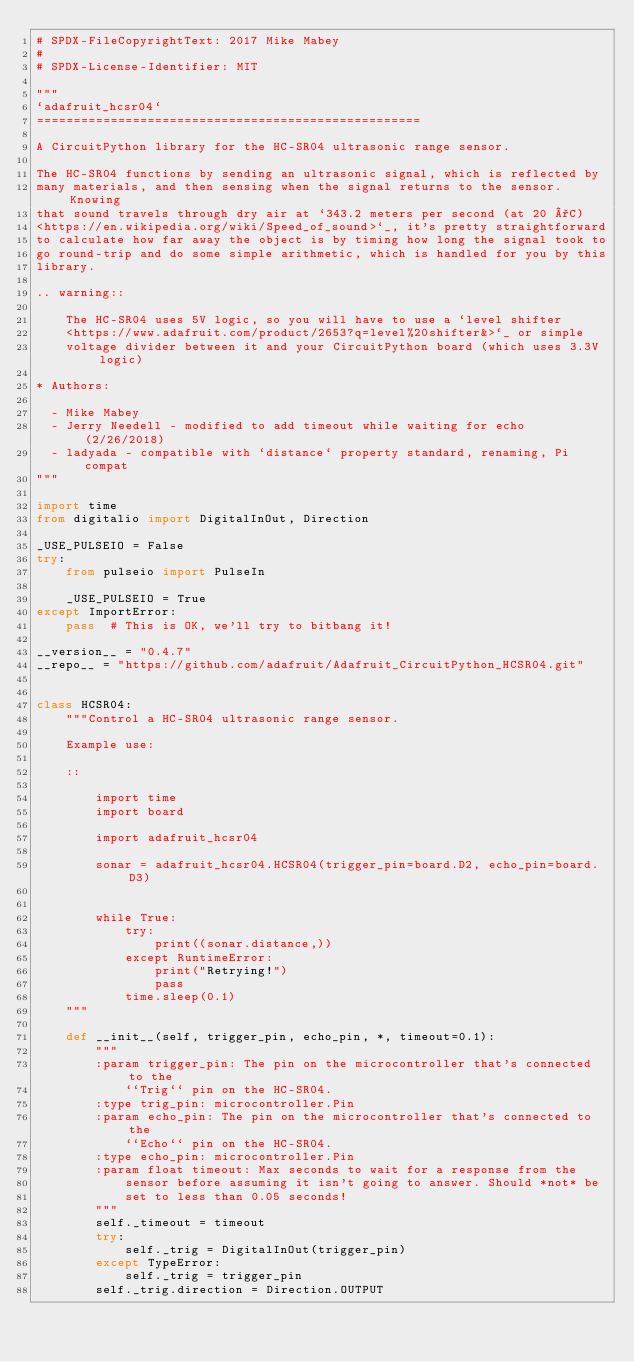<code> <loc_0><loc_0><loc_500><loc_500><_Python_># SPDX-FileCopyrightText: 2017 Mike Mabey
#
# SPDX-License-Identifier: MIT

"""
`adafruit_hcsr04`
====================================================

A CircuitPython library for the HC-SR04 ultrasonic range sensor.

The HC-SR04 functions by sending an ultrasonic signal, which is reflected by
many materials, and then sensing when the signal returns to the sensor. Knowing
that sound travels through dry air at `343.2 meters per second (at 20 °C)
<https://en.wikipedia.org/wiki/Speed_of_sound>`_, it's pretty straightforward
to calculate how far away the object is by timing how long the signal took to
go round-trip and do some simple arithmetic, which is handled for you by this
library.

.. warning::

    The HC-SR04 uses 5V logic, so you will have to use a `level shifter
    <https://www.adafruit.com/product/2653?q=level%20shifter&>`_ or simple
    voltage divider between it and your CircuitPython board (which uses 3.3V logic)

* Authors:

  - Mike Mabey
  - Jerry Needell - modified to add timeout while waiting for echo (2/26/2018)
  - ladyada - compatible with `distance` property standard, renaming, Pi compat
"""

import time
from digitalio import DigitalInOut, Direction

_USE_PULSEIO = False
try:
    from pulseio import PulseIn

    _USE_PULSEIO = True
except ImportError:
    pass  # This is OK, we'll try to bitbang it!

__version__ = "0.4.7"
__repo__ = "https://github.com/adafruit/Adafruit_CircuitPython_HCSR04.git"


class HCSR04:
    """Control a HC-SR04 ultrasonic range sensor.

    Example use:

    ::

        import time
        import board

        import adafruit_hcsr04

        sonar = adafruit_hcsr04.HCSR04(trigger_pin=board.D2, echo_pin=board.D3)


        while True:
            try:
                print((sonar.distance,))
            except RuntimeError:
                print("Retrying!")
                pass
            time.sleep(0.1)
    """

    def __init__(self, trigger_pin, echo_pin, *, timeout=0.1):
        """
        :param trigger_pin: The pin on the microcontroller that's connected to the
            ``Trig`` pin on the HC-SR04.
        :type trig_pin: microcontroller.Pin
        :param echo_pin: The pin on the microcontroller that's connected to the
            ``Echo`` pin on the HC-SR04.
        :type echo_pin: microcontroller.Pin
        :param float timeout: Max seconds to wait for a response from the
            sensor before assuming it isn't going to answer. Should *not* be
            set to less than 0.05 seconds!
        """
        self._timeout = timeout
        try:
            self._trig = DigitalInOut(trigger_pin)
        except TypeError:
            self._trig = trigger_pin
        self._trig.direction = Direction.OUTPUT
</code> 